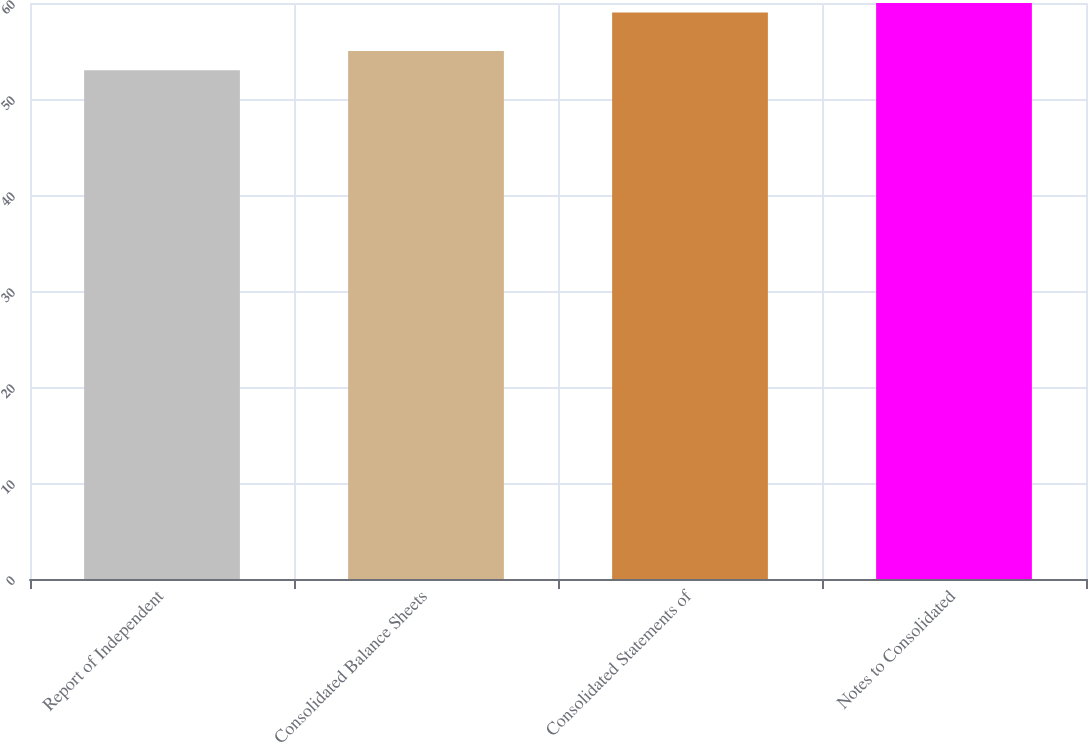Convert chart to OTSL. <chart><loc_0><loc_0><loc_500><loc_500><bar_chart><fcel>Report of Independent<fcel>Consolidated Balance Sheets<fcel>Consolidated Statements of<fcel>Notes to Consolidated<nl><fcel>53<fcel>55<fcel>59<fcel>60<nl></chart> 